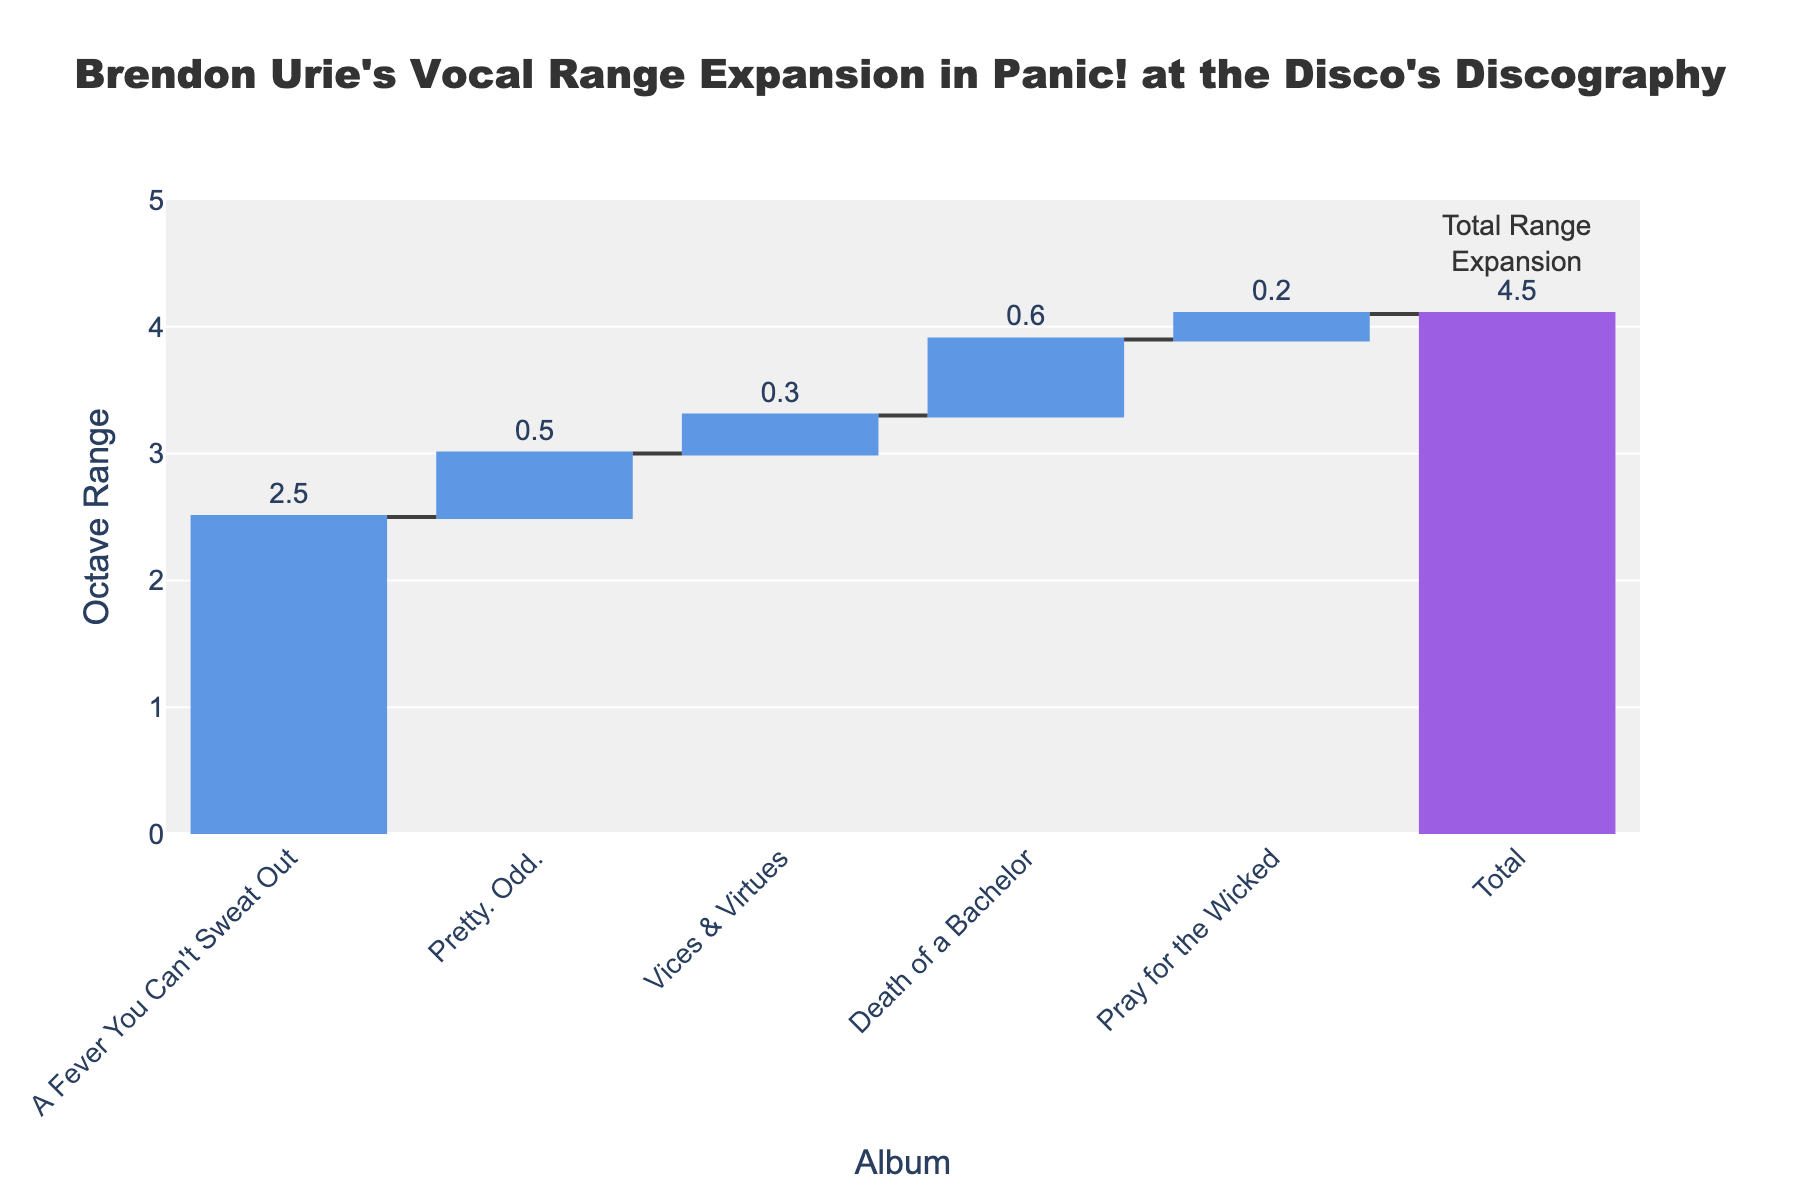what is the title of the chart? The title of the chart is located at the top of the figure and is typically in a larger and bold font. By looking at the top of the chart, we can clearly see the title.
Answer: Brendon Urie's Vocal Range Expansion in Panic! at the Disco's Discography which album resulted in the largest cumulative change in vocal range? By examining the y-values corresponding to each album, where the cumulative change reaches its peak, we can determine the album with the greatest impact on vocal range.
Answer: Death of a Bachelor how much did Brendon Urie's vocal range expand from "A Fever You Can't Sweat Out" to "Pretty. Odd."? First, find the y-values for "A Fever You Can't Sweat Out" and "Pretty. Odd.". Subtract the former from the latter to get the range expansion. 3 - 2.5 = 0.5
Answer: 0.5 octaves compare the cumulative change in vocal range between "Vices & Virtues" and "Pray for the Wicked". Which had a larger impact? Locate the y-values for "Vices & Virtues" and "Pray for the Wicked". Compare these values directly. 3.3 (Vices & Virtues) vs 4.5 (Pray for the Wicked)
Answer: Pray for the Wicked what is the total range expansion shown in the chart? Examine the y-value associated with the "Total" bar. The "Total" value represents the overall increase across all albums.
Answer: 4.5 octaves in which album did Brendon Urie's vocal range expand the least? By examining the height of each waterfall segment (bar), we can identify the album that shows the smallest increase in the vocal range.
Answer: Pray for the Wicked calculate the average octave range expansion per album. Sum the octave ranges for each album and divide by the total number of albums. (2.5 + 0.5 + 0.3 + 0.6 + 0.2) / 5 = 4.1 / 5 = 0.82
Answer: 0.82 octaves how does the vocal range expansion in "A Fever You Can't Sweat Out" compare to the rest of the albums? Compare the height of the waterfall segment for "A Fever You Can't Sweat Out" to the segments of other albums.
Answer: Largest single segment expansion which albums have a vocal range expansion less than 1 octave? By reviewing the y-values for each album's segment, identify those values that are less than 1.
Answer: Pretty. Odd., Vices & Virtues, Pray for the Wicked 